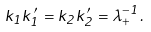<formula> <loc_0><loc_0><loc_500><loc_500>k _ { 1 } k _ { 1 } ^ { \prime } = k _ { 2 } k _ { 2 } ^ { \prime } = \lambda _ { + } ^ { - 1 } .</formula> 